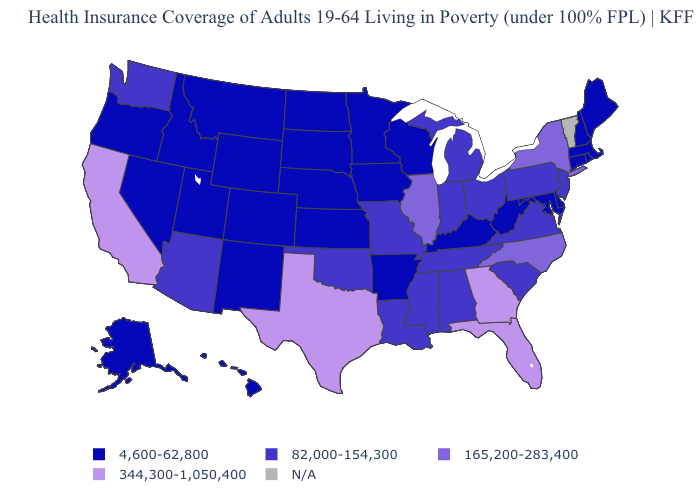Name the states that have a value in the range 165,200-283,400?
Give a very brief answer. Illinois, New York, North Carolina. Name the states that have a value in the range N/A?
Quick response, please. Vermont. What is the value of Massachusetts?
Quick response, please. 4,600-62,800. Does the first symbol in the legend represent the smallest category?
Short answer required. Yes. Which states have the lowest value in the Northeast?
Quick response, please. Connecticut, Maine, Massachusetts, New Hampshire, Rhode Island. Which states have the lowest value in the USA?
Give a very brief answer. Alaska, Arkansas, Colorado, Connecticut, Delaware, Hawaii, Idaho, Iowa, Kansas, Kentucky, Maine, Maryland, Massachusetts, Minnesota, Montana, Nebraska, Nevada, New Hampshire, New Mexico, North Dakota, Oregon, Rhode Island, South Dakota, Utah, West Virginia, Wisconsin, Wyoming. Name the states that have a value in the range 165,200-283,400?
Quick response, please. Illinois, New York, North Carolina. What is the highest value in states that border Maryland?
Short answer required. 82,000-154,300. What is the highest value in the USA?
Give a very brief answer. 344,300-1,050,400. What is the lowest value in the West?
Keep it brief. 4,600-62,800. Name the states that have a value in the range N/A?
Quick response, please. Vermont. What is the lowest value in the Northeast?
Be succinct. 4,600-62,800. Does the first symbol in the legend represent the smallest category?
Answer briefly. Yes. What is the lowest value in states that border Nevada?
Keep it brief. 4,600-62,800. 